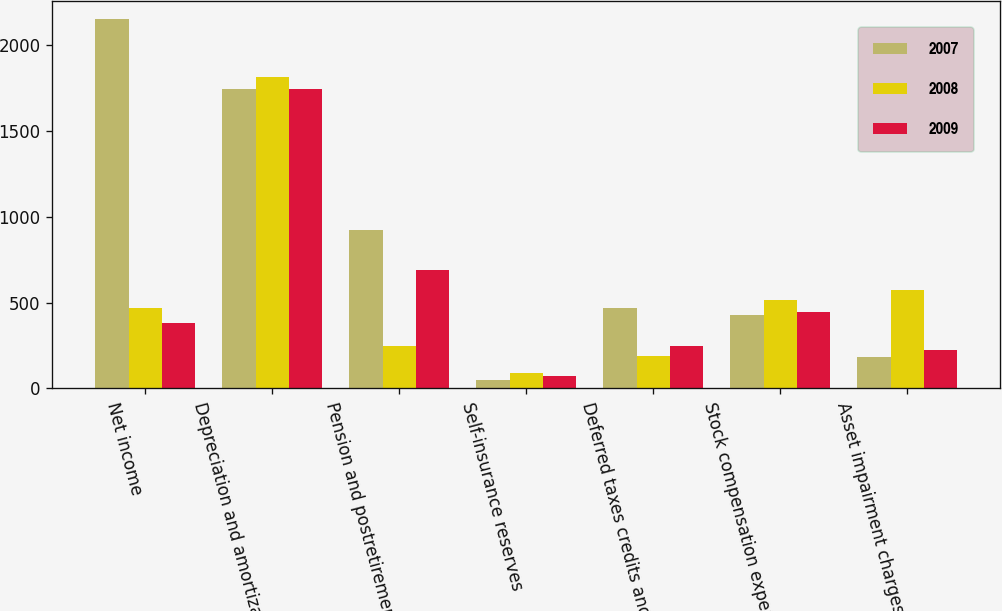<chart> <loc_0><loc_0><loc_500><loc_500><stacked_bar_chart><ecel><fcel>Net income<fcel>Depreciation and amortization<fcel>Pension and postretirement<fcel>Self-insurance reserves<fcel>Deferred taxes credits and<fcel>Stock compensation expense<fcel>Asset impairment charges<nl><fcel>2007<fcel>2152<fcel>1747<fcel>924<fcel>47<fcel>471<fcel>430<fcel>181<nl><fcel>2008<fcel>471<fcel>1814<fcel>246<fcel>87<fcel>187<fcel>516<fcel>575<nl><fcel>2009<fcel>382<fcel>1745<fcel>687<fcel>69<fcel>249<fcel>447<fcel>221<nl></chart> 